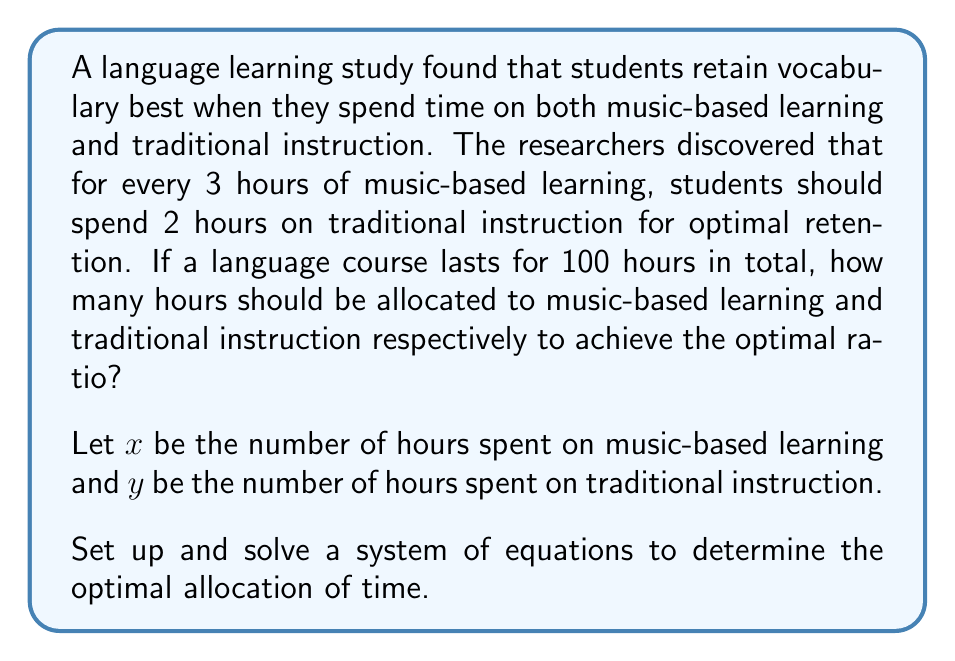Provide a solution to this math problem. To solve this problem, we need to set up a system of two equations based on the given information:

1. The total course duration is 100 hours:
   $$x + y = 100$$

2. The optimal ratio of music-based learning to traditional instruction is 3:2:
   $$\frac{x}{3} = \frac{y}{2}$$

Now we can solve this system of equations:

1. From the second equation, we can express $x$ in terms of $y$:
   $$x = \frac{3y}{2}$$

2. Substitute this expression into the first equation:
   $$\frac{3y}{2} + y = 100$$

3. Simplify:
   $$\frac{3y}{2} + \frac{2y}{2} = 100$$
   $$\frac{5y}{2} = 100$$

4. Multiply both sides by 2:
   $$5y = 200$$

5. Solve for $y$:
   $$y = 40$$

6. Now that we know $y$, we can find $x$ using either of the original equations. Let's use the first one:
   $$x + 40 = 100$$
   $$x = 60$$

7. Verify the ratio:
   $$\frac{x}{y} = \frac{60}{40} = \frac{3}{2}$$

Therefore, the optimal allocation is 60 hours for music-based learning and 40 hours for traditional instruction.
Answer: Music-based learning: 60 hours
Traditional instruction: 40 hours 